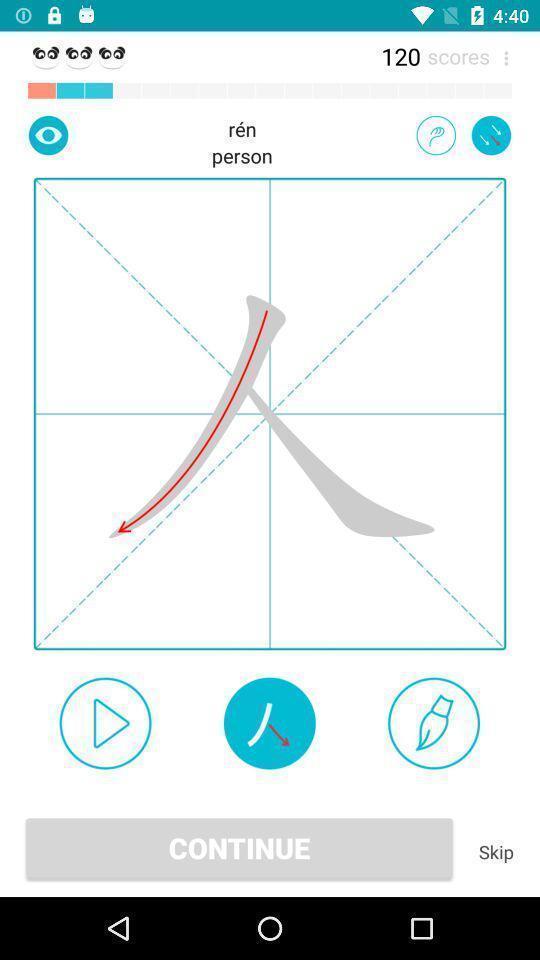Tell me what you see in this picture. Screen shows continue option. 